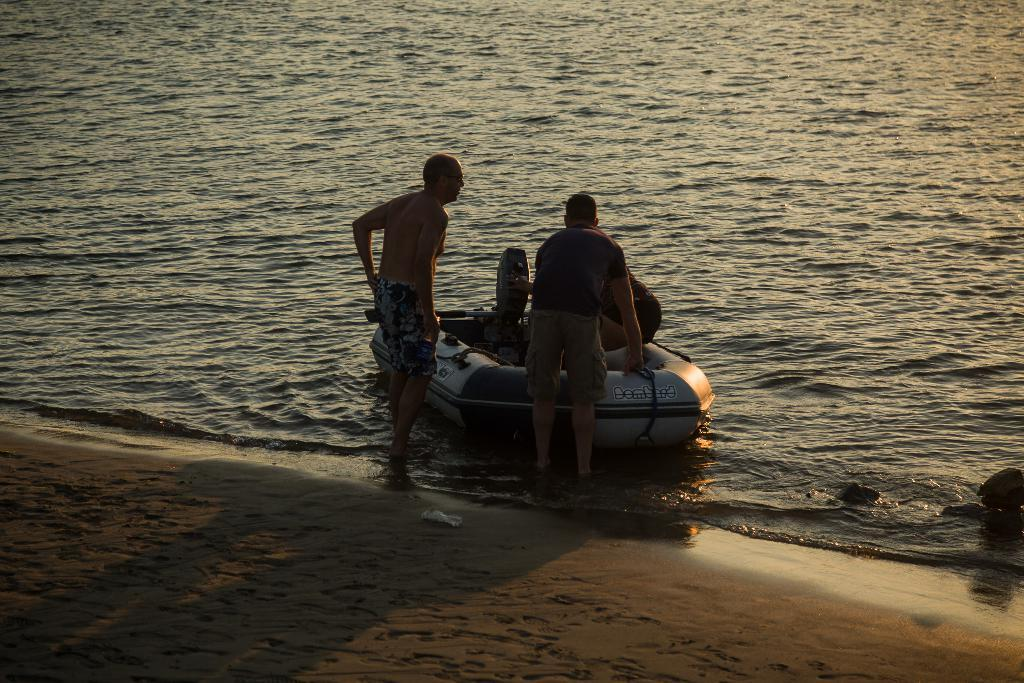What is happening in the image? There are people standing in the image, and one person is on a raft. What is the environment like in the image? There is water visible in the image. What type of ladybug can be seen playing a guitar in the image? There is no ladybug or guitar present in the image. 